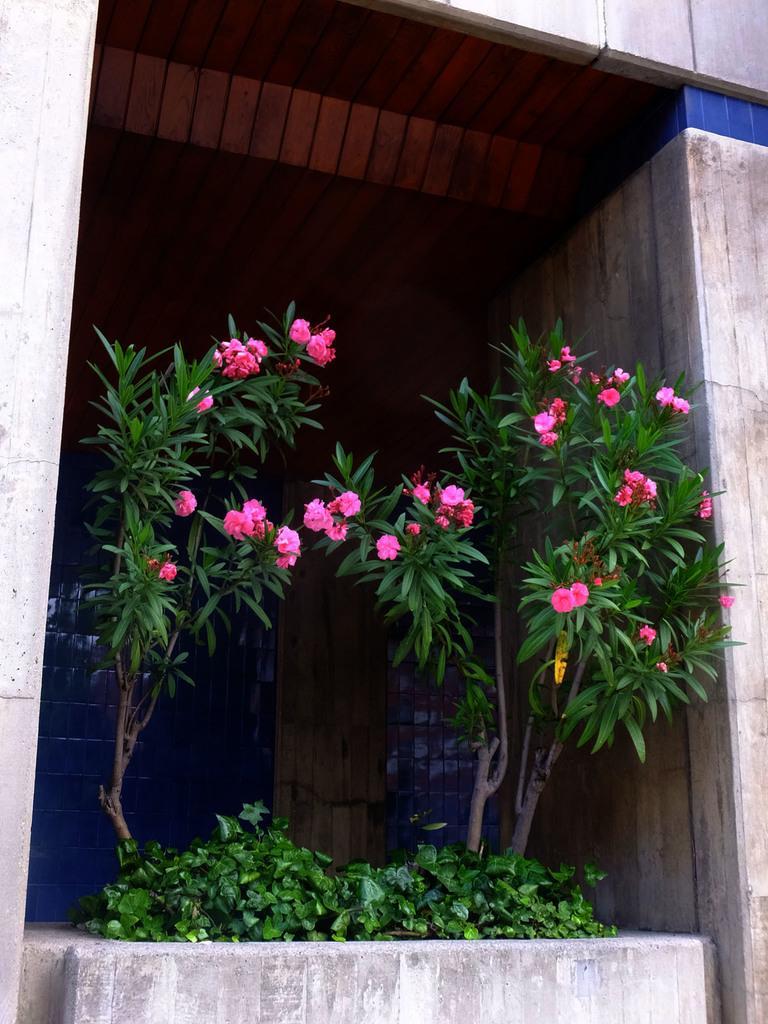In one or two sentences, can you explain what this image depicts? This picture looks like a building and I can see plants with flowers. 